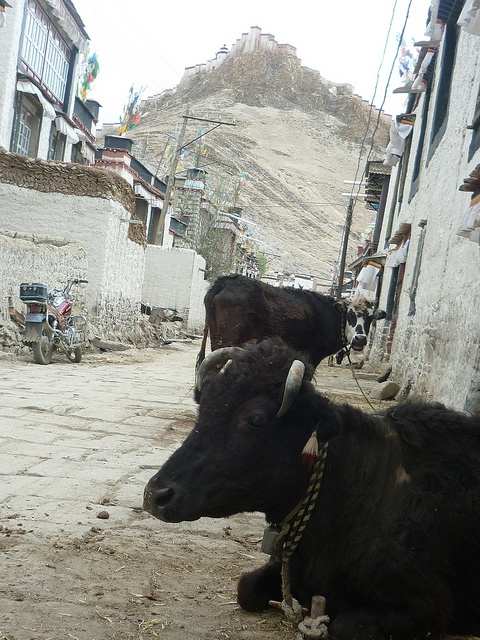Describe the objects in this image and their specific colors. I can see cow in gray, black, and darkgray tones, cow in gray, black, and darkgray tones, and motorcycle in gray, darkgray, black, and lightgray tones in this image. 